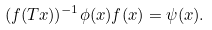<formula> <loc_0><loc_0><loc_500><loc_500>( f ( T x ) ) ^ { - 1 } \phi ( x ) f ( x ) = \psi ( x ) .</formula> 